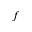<formula> <loc_0><loc_0><loc_500><loc_500>f</formula> 